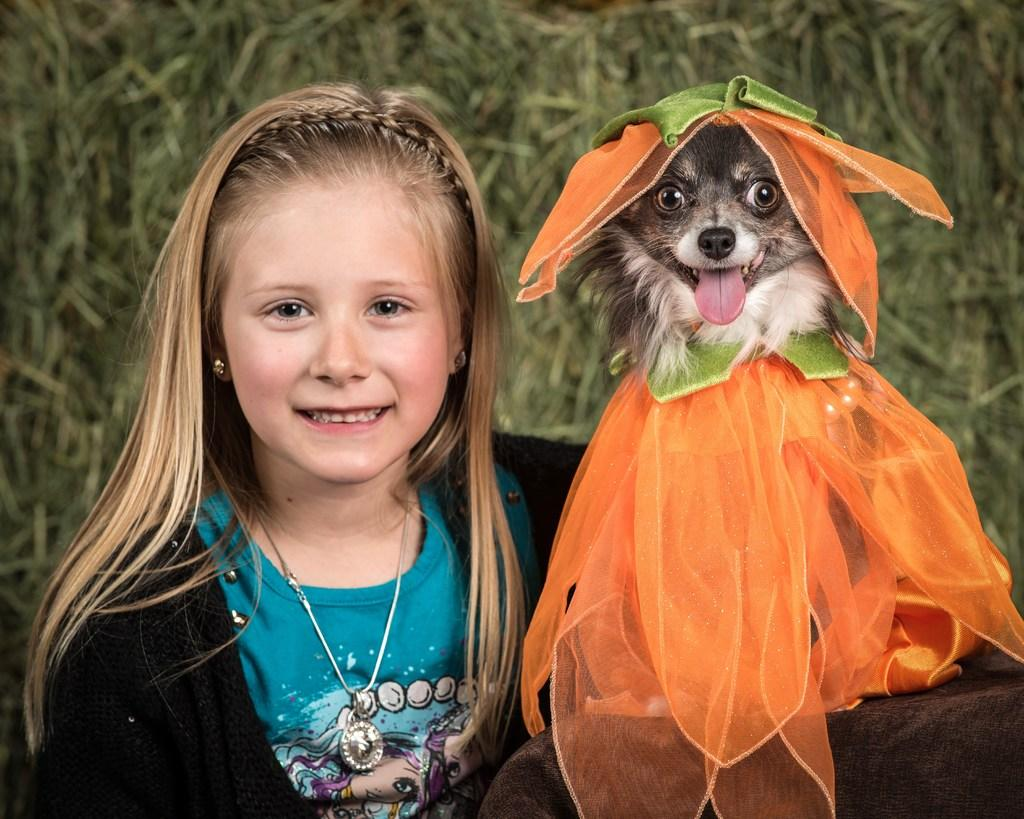Who or what is present in the image? There is a person and a dog in the image. What can be seen in the background of the image? There is a plant in the background of the image. What type of grape is being used as a leash for the dog in the image? There is no grape present in the image, nor is it being used as a leash for the dog. 